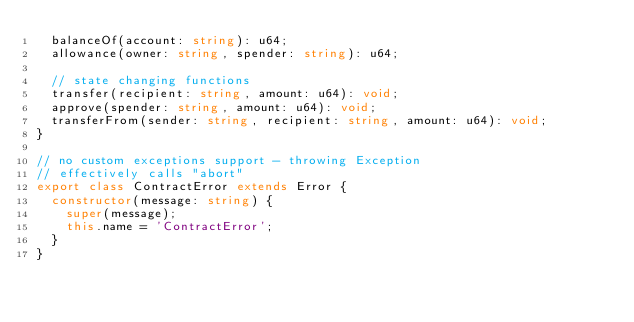<code> <loc_0><loc_0><loc_500><loc_500><_TypeScript_>  balanceOf(account: string): u64;
  allowance(owner: string, spender: string): u64;

  // state changing functions
  transfer(recipient: string, amount: u64): void;
  approve(spender: string, amount: u64): void;
  transferFrom(sender: string, recipient: string, amount: u64): void;
}

// no custom exceptions support - throwing Exception
// effectively calls "abort"
export class ContractError extends Error {
  constructor(message: string) {
    super(message);
    this.name = 'ContractError';
  }
}
</code> 